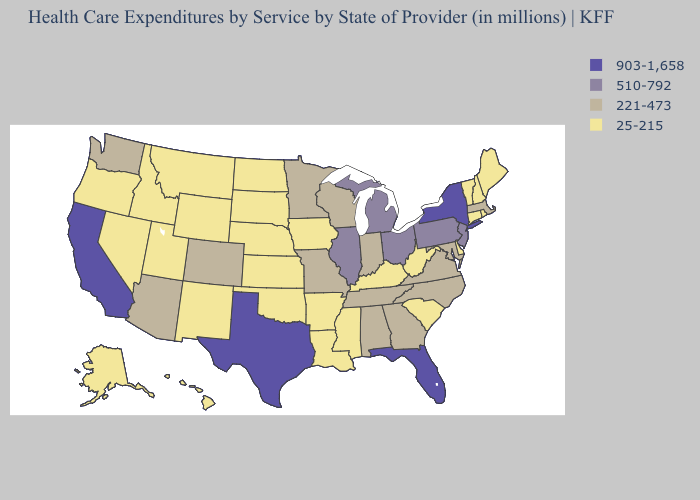What is the lowest value in the West?
Short answer required. 25-215. Name the states that have a value in the range 510-792?
Keep it brief. Illinois, Michigan, New Jersey, Ohio, Pennsylvania. What is the value of Illinois?
Give a very brief answer. 510-792. What is the value of Rhode Island?
Be succinct. 25-215. Does Colorado have a higher value than Minnesota?
Give a very brief answer. No. What is the value of Alaska?
Give a very brief answer. 25-215. Does Wisconsin have the same value as New Jersey?
Short answer required. No. Which states have the highest value in the USA?
Answer briefly. California, Florida, New York, Texas. What is the value of Texas?
Short answer required. 903-1,658. What is the highest value in the West ?
Concise answer only. 903-1,658. Which states have the lowest value in the USA?
Short answer required. Alaska, Arkansas, Connecticut, Delaware, Hawaii, Idaho, Iowa, Kansas, Kentucky, Louisiana, Maine, Mississippi, Montana, Nebraska, Nevada, New Hampshire, New Mexico, North Dakota, Oklahoma, Oregon, Rhode Island, South Carolina, South Dakota, Utah, Vermont, West Virginia, Wyoming. Which states hav the highest value in the South?
Concise answer only. Florida, Texas. Name the states that have a value in the range 25-215?
Quick response, please. Alaska, Arkansas, Connecticut, Delaware, Hawaii, Idaho, Iowa, Kansas, Kentucky, Louisiana, Maine, Mississippi, Montana, Nebraska, Nevada, New Hampshire, New Mexico, North Dakota, Oklahoma, Oregon, Rhode Island, South Carolina, South Dakota, Utah, Vermont, West Virginia, Wyoming. Does the map have missing data?
Answer briefly. No. Which states have the lowest value in the USA?
Be succinct. Alaska, Arkansas, Connecticut, Delaware, Hawaii, Idaho, Iowa, Kansas, Kentucky, Louisiana, Maine, Mississippi, Montana, Nebraska, Nevada, New Hampshire, New Mexico, North Dakota, Oklahoma, Oregon, Rhode Island, South Carolina, South Dakota, Utah, Vermont, West Virginia, Wyoming. 